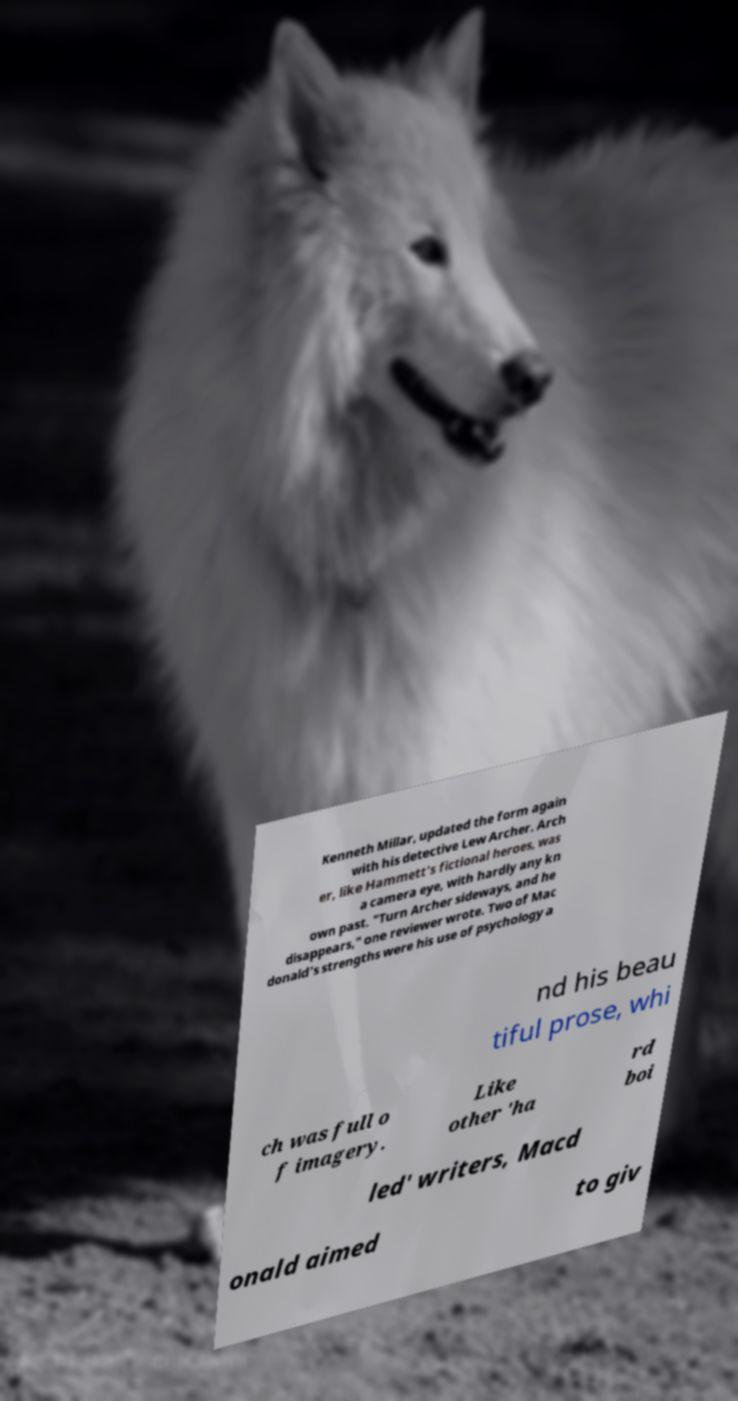I need the written content from this picture converted into text. Can you do that? Kenneth Millar, updated the form again with his detective Lew Archer. Arch er, like Hammett's fictional heroes, was a camera eye, with hardly any kn own past. "Turn Archer sideways, and he disappears," one reviewer wrote. Two of Mac donald's strengths were his use of psychology a nd his beau tiful prose, whi ch was full o f imagery. Like other 'ha rd boi led' writers, Macd onald aimed to giv 